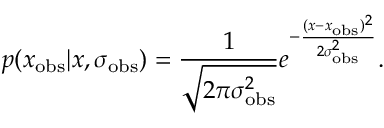<formula> <loc_0><loc_0><loc_500><loc_500>p ( x _ { o b s } | x , \sigma _ { o b s } ) = \frac { 1 } { \sqrt { 2 \pi \sigma _ { o b s } ^ { 2 } } } e ^ { - \frac { ( x - x _ { o b s } ) ^ { 2 } } { 2 \sigma _ { o b s } ^ { 2 } } } .</formula> 